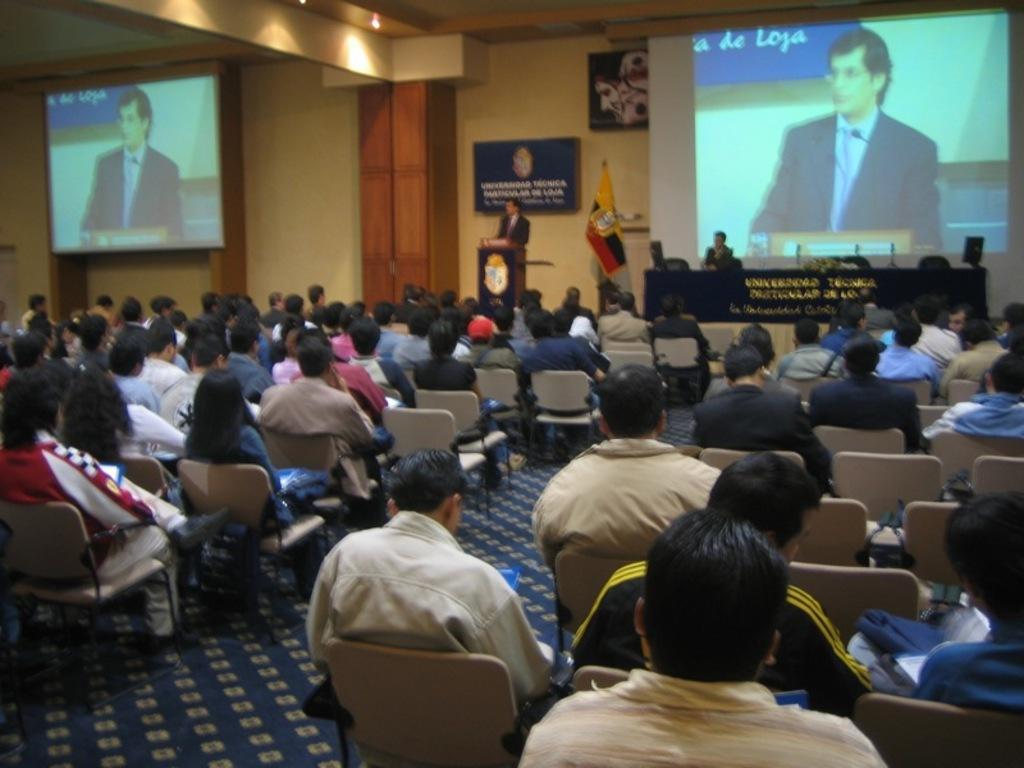How would you summarize this image in a sentence or two? In the center of the image we can see a man standing, before him there is a podium and there are people sitting. We can see a flag. There is a table. In the background there are screens and boards placed on the wall. At the top there are lights. 